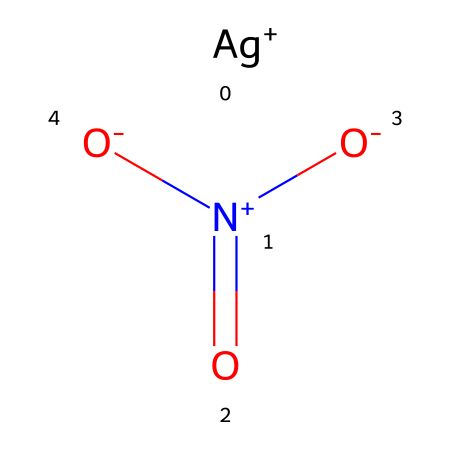What is the name of this chemical? The SMILES representation indicates the presence of silver (Ag) and a nitrate group (NO3) combined, which refers to the chemical name silver nitrate.
Answer: silver nitrate How many oxygen atoms are present in this molecule? The nitrate group (NO3) contains three oxygen atoms, and there are no additional oxygen atoms indicated in the SMILES structure.
Answer: three What is the charge of the silver ion in this compound? The notation [Ag+] indicates that the silver ion carries a positive charge of +1.
Answer: +1 What type of chemical bond connects the silver ion and the nitrate group? The bonds between the silver ion and the nitrate group are primarily ionic, as indicated by the presence of charged species.
Answer: ionic How does this chemical behave in the presence of light? Silver nitrate is known to be photoreactive, meaning it decomposes upon exposure to light, forming silver metal and other products.
Answer: photoreactive What is the primary function of silver nitrate in album cover printing? In album cover printing, silver nitrate acts as a photosensitive agent, helping to create images when exposed to light.
Answer: photosensitive agent 